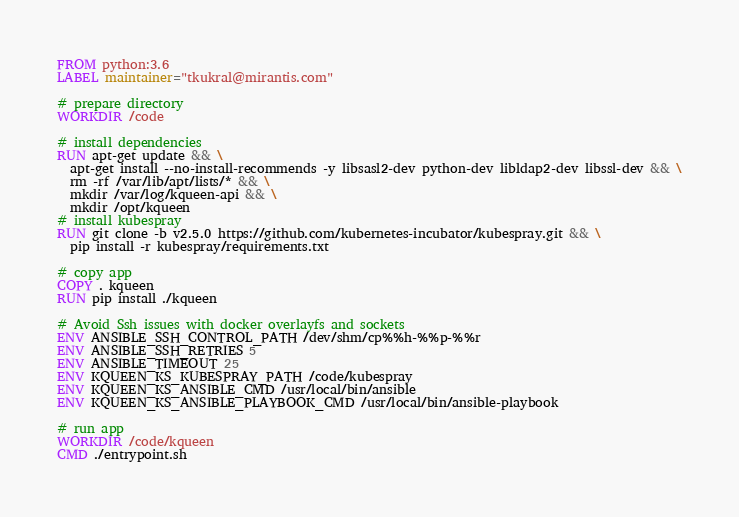Convert code to text. <code><loc_0><loc_0><loc_500><loc_500><_Dockerfile_>FROM python:3.6
LABEL maintainer="tkukral@mirantis.com"

# prepare directory
WORKDIR /code

# install dependencies
RUN apt-get update && \
  apt-get install --no-install-recommends -y libsasl2-dev python-dev libldap2-dev libssl-dev && \
  rm -rf /var/lib/apt/lists/* && \
  mkdir /var/log/kqueen-api && \
  mkdir /opt/kqueen
# install kubespray
RUN git clone -b v2.5.0 https://github.com/kubernetes-incubator/kubespray.git && \
  pip install -r kubespray/requirements.txt

# copy app
COPY . kqueen
RUN pip install ./kqueen

# Avoid Ssh issues with docker overlayfs and sockets
ENV ANSIBLE_SSH_CONTROL_PATH /dev/shm/cp%%h-%%p-%%r
ENV ANSIBLE_SSH_RETRIES 5
ENV ANSIBLE_TIMEOUT 25
ENV KQUEEN_KS_KUBESPRAY_PATH /code/kubespray
ENV KQUEEN_KS_ANSIBLE_CMD /usr/local/bin/ansible
ENV KQUEEN_KS_ANSIBLE_PLAYBOOK_CMD /usr/local/bin/ansible-playbook

# run app
WORKDIR /code/kqueen
CMD ./entrypoint.sh
</code> 